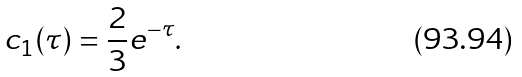<formula> <loc_0><loc_0><loc_500><loc_500>c _ { 1 } ( \tau ) = \frac { 2 } { 3 } e ^ { - \tau } .</formula> 